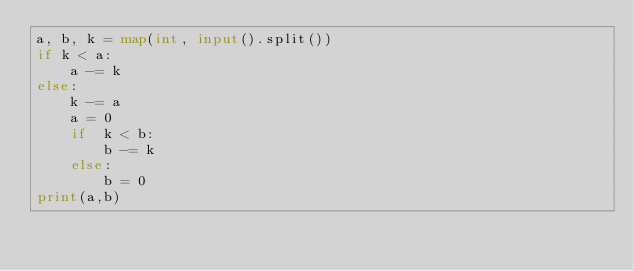Convert code to text. <code><loc_0><loc_0><loc_500><loc_500><_Python_>a, b, k = map(int, input().split())
if k < a:
    a -= k
else:
    k -= a
    a = 0
    if  k < b:
        b -= k
    else:
        b = 0
print(a,b)</code> 